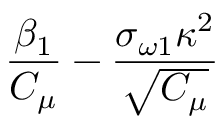Convert formula to latex. <formula><loc_0><loc_0><loc_500><loc_500>\frac { \beta _ { 1 } } { C _ { \mu } } - \frac { \sigma _ { \omega 1 } \kappa ^ { 2 } } { \sqrt { C _ { \mu } } }</formula> 